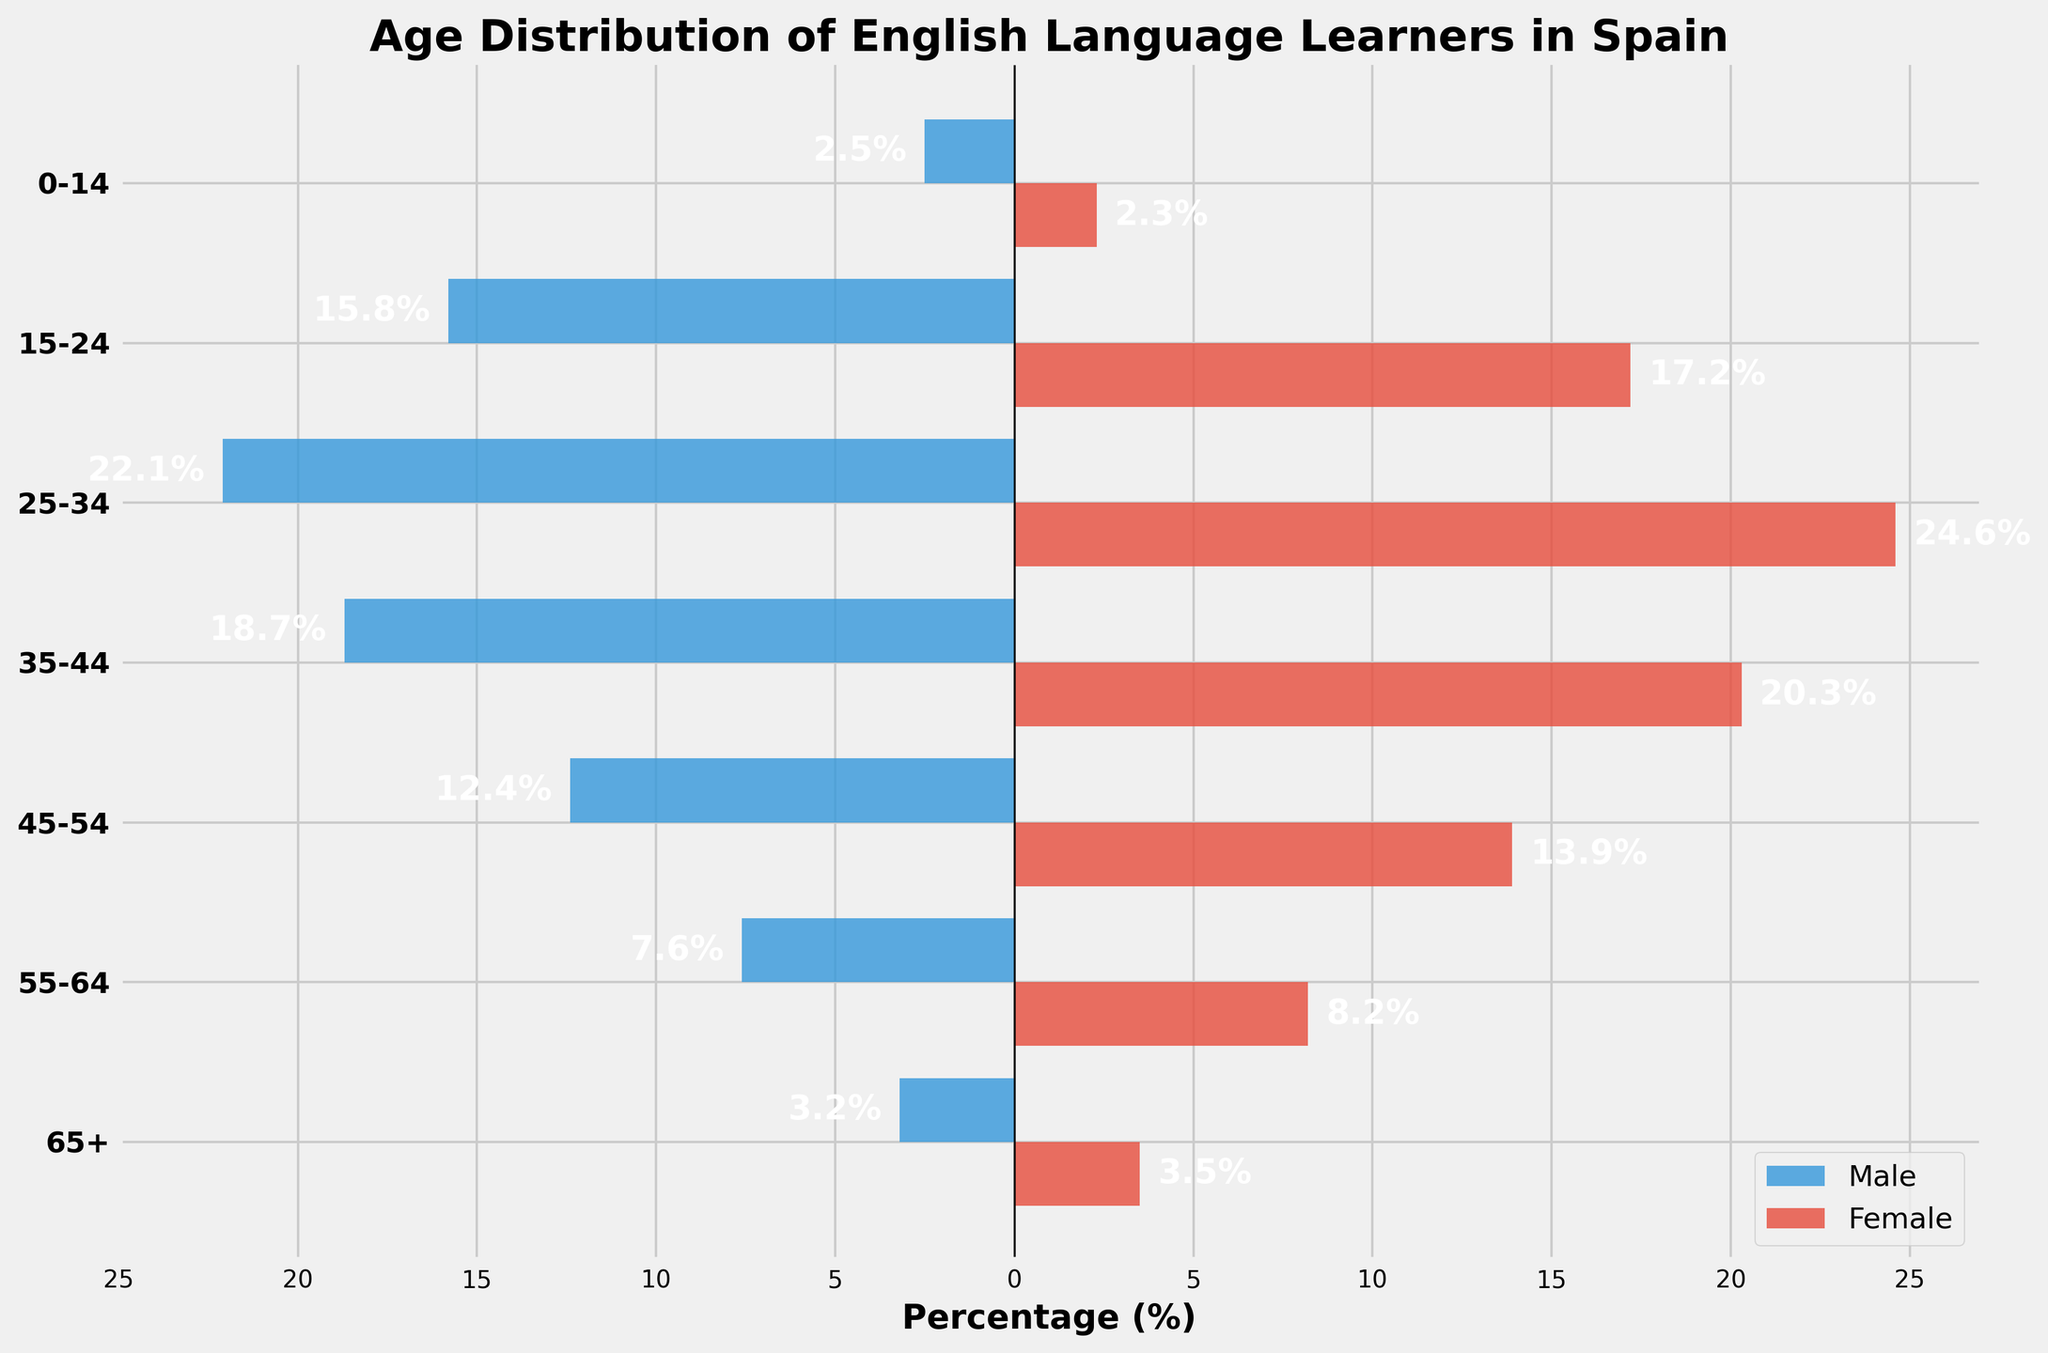What is the title of the figure? The figure's title is prominently displayed at the top and provides the main information about the chart. The title is placed there to quickly orient the viewer to the purpose of the chart.
Answer: Age Distribution of English Language Learners in Spain Which age group has the highest percentage of English language learners for both males and females? By observing the length of the bars, the age group with the highest percentage will have the longest bars for both males and females. The categories are labeled along the y-axis.
Answer: 25-34 Which age group has the least percentage of male English language learners? Look for the shortest bar among the male category, which is represented by the bars extending to the left side of the graph.
Answer: 0-14 How does the percentage of female English language learners in the 45-54 age group compare to that in the 55-64 age group? Identify the length of the bars for the 45-54 and 55-64 age groups for females. Compare the lengths to see which is longer or if they are equal.
Answer: 45-54 has a higher percentage What is the combined percentage of male and female English language learners in the 35-44 age group? Sum the absolute value of the male percentage (since it is displayed negatively) and the female percentage for the 35-44 age group.
Answer: 39.0% How many age groups have a higher percentage of female learners than male learners? Compare the length of the female bars to the male bars for each age group. Count the number of age groups where the female bar is longer.
Answer: Six What is the percentage difference between male and female learners in the 25-34 age group? Subtract the male percentage from the female percentage for the 25-34 age group. The male percentage is negative, so it becomes a sum.
Answer: 2.5% Which gender has a higher percentage of English language learners in the 65+ age group, and by how much? Compare the length of the bars for the 65+ age group, and calculate the difference.
Answer: Females by 0.3% What is the range of percentages for male learners across all age groups? Identify the maximum and minimum percentages for male learners and calculate the range by subtracting the smallest percentage from the largest. The values are all given as negative.
Answer: 19.6% How do the trends in English language learning differ between males and females across the different age groups? Observe the patterns in bar lengths for males and females across all age categories. Note which age groups show significant differences and which are more balanced.
Answer: Females consistently have higher percentages across all age groups 